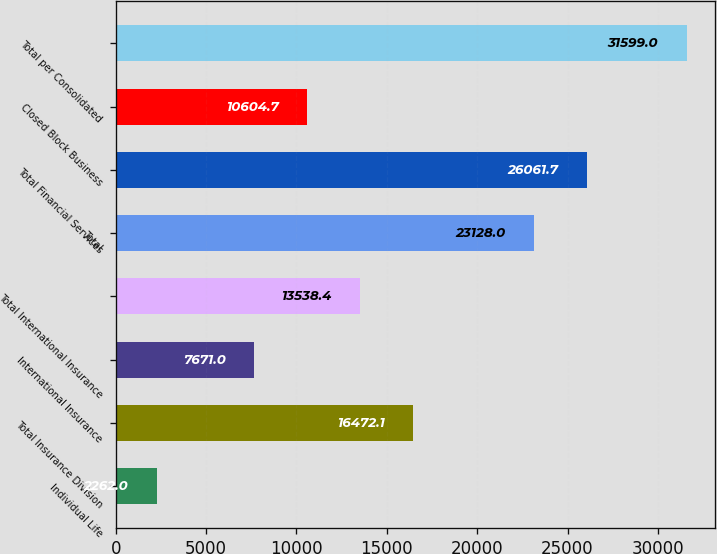Convert chart. <chart><loc_0><loc_0><loc_500><loc_500><bar_chart><fcel>Individual Life<fcel>Total Insurance Division<fcel>International Insurance<fcel>Total International Insurance<fcel>Total<fcel>Total Financial Services<fcel>Closed Block Business<fcel>Total per Consolidated<nl><fcel>2262<fcel>16472.1<fcel>7671<fcel>13538.4<fcel>23128<fcel>26061.7<fcel>10604.7<fcel>31599<nl></chart> 